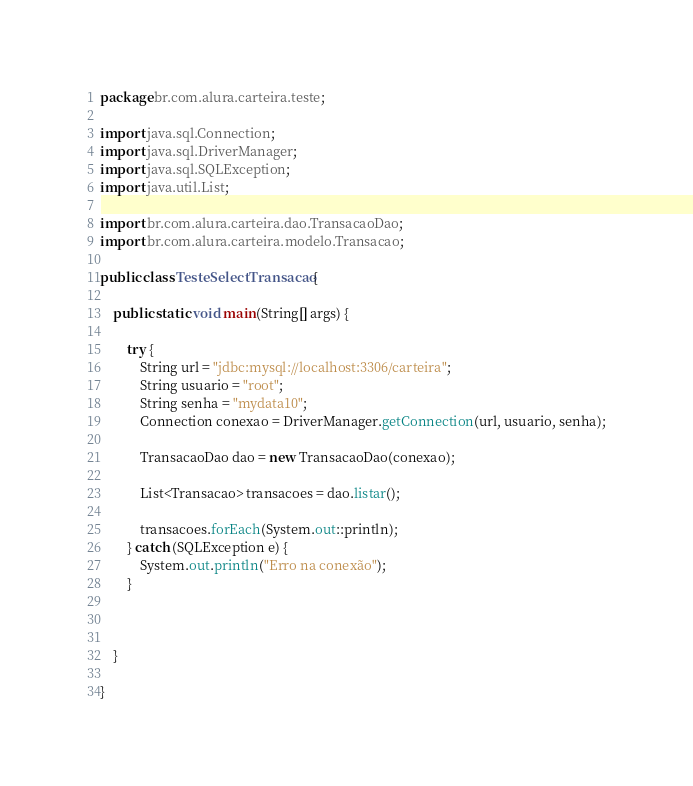Convert code to text. <code><loc_0><loc_0><loc_500><loc_500><_Java_>package br.com.alura.carteira.teste;

import java.sql.Connection;
import java.sql.DriverManager;
import java.sql.SQLException;
import java.util.List;

import br.com.alura.carteira.dao.TransacaoDao;
import br.com.alura.carteira.modelo.Transacao;

public class TesteSelectTransacao {

	public static void main(String[] args) {
		
		try {
			String url = "jdbc:mysql://localhost:3306/carteira";
			String usuario = "root";
			String senha = "mydata10";
			Connection conexao = DriverManager.getConnection(url, usuario, senha);
			
			TransacaoDao dao = new TransacaoDao(conexao);
			
			List<Transacao> transacoes = dao.listar();
			
			transacoes.forEach(System.out::println);
		} catch (SQLException e) {
			System.out.println("Erro na conexão");
		}
		
		

	}

}
</code> 